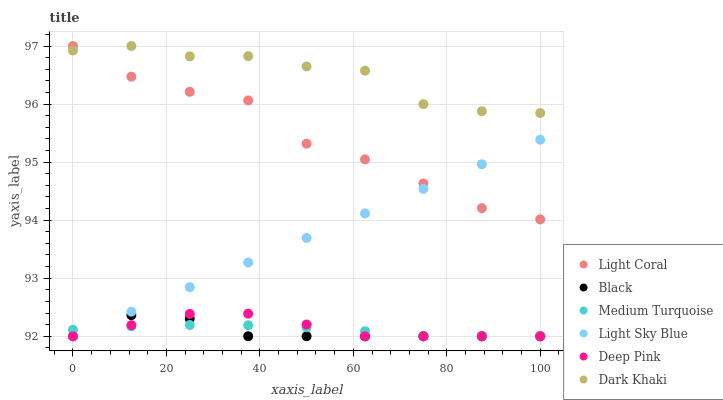Does Black have the minimum area under the curve?
Answer yes or no. Yes. Does Dark Khaki have the maximum area under the curve?
Answer yes or no. Yes. Does Deep Pink have the minimum area under the curve?
Answer yes or no. No. Does Deep Pink have the maximum area under the curve?
Answer yes or no. No. Is Light Sky Blue the smoothest?
Answer yes or no. Yes. Is Light Coral the roughest?
Answer yes or no. Yes. Is Deep Pink the smoothest?
Answer yes or no. No. Is Deep Pink the roughest?
Answer yes or no. No. Does Deep Pink have the lowest value?
Answer yes or no. Yes. Does Light Coral have the lowest value?
Answer yes or no. No. Does Light Coral have the highest value?
Answer yes or no. Yes. Does Deep Pink have the highest value?
Answer yes or no. No. Is Black less than Light Coral?
Answer yes or no. Yes. Is Dark Khaki greater than Medium Turquoise?
Answer yes or no. Yes. Does Black intersect Light Sky Blue?
Answer yes or no. Yes. Is Black less than Light Sky Blue?
Answer yes or no. No. Is Black greater than Light Sky Blue?
Answer yes or no. No. Does Black intersect Light Coral?
Answer yes or no. No. 